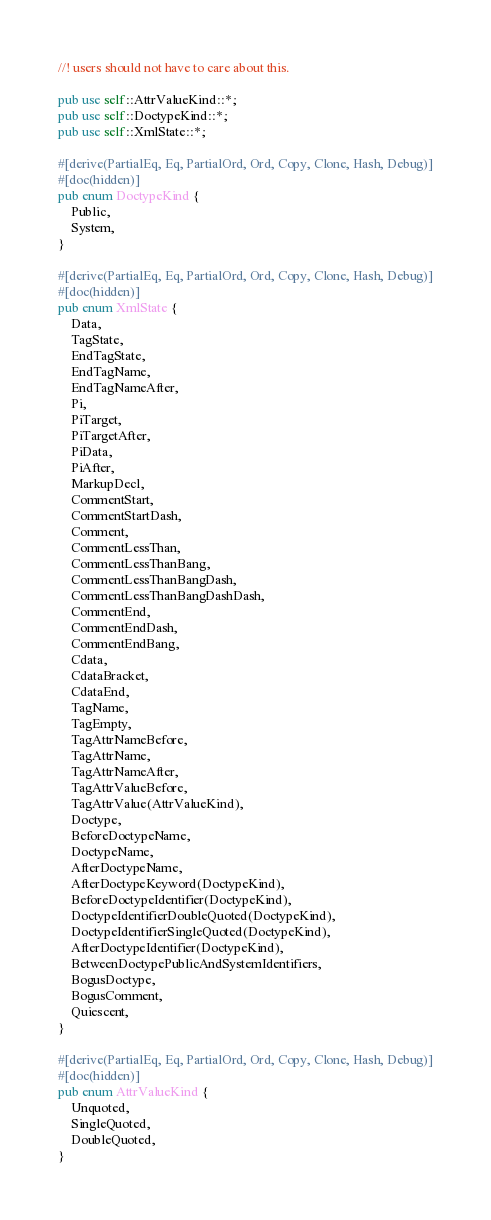<code> <loc_0><loc_0><loc_500><loc_500><_Rust_>//! users should not have to care about this.

pub use self::AttrValueKind::*;
pub use self::DoctypeKind::*;
pub use self::XmlState::*;

#[derive(PartialEq, Eq, PartialOrd, Ord, Copy, Clone, Hash, Debug)]
#[doc(hidden)]
pub enum DoctypeKind {
    Public,
    System,
}

#[derive(PartialEq, Eq, PartialOrd, Ord, Copy, Clone, Hash, Debug)]
#[doc(hidden)]
pub enum XmlState {
    Data,
    TagState,
    EndTagState,
    EndTagName,
    EndTagNameAfter,
    Pi,
    PiTarget,
    PiTargetAfter,
    PiData,
    PiAfter,
    MarkupDecl,
    CommentStart,
    CommentStartDash,
    Comment,
    CommentLessThan,
    CommentLessThanBang,
    CommentLessThanBangDash,
    CommentLessThanBangDashDash,
    CommentEnd,
    CommentEndDash,
    CommentEndBang,
    Cdata,
    CdataBracket,
    CdataEnd,
    TagName,
    TagEmpty,
    TagAttrNameBefore,
    TagAttrName,
    TagAttrNameAfter,
    TagAttrValueBefore,
    TagAttrValue(AttrValueKind),
    Doctype,
    BeforeDoctypeName,
    DoctypeName,
    AfterDoctypeName,
    AfterDoctypeKeyword(DoctypeKind),
    BeforeDoctypeIdentifier(DoctypeKind),
    DoctypeIdentifierDoubleQuoted(DoctypeKind),
    DoctypeIdentifierSingleQuoted(DoctypeKind),
    AfterDoctypeIdentifier(DoctypeKind),
    BetweenDoctypePublicAndSystemIdentifiers,
    BogusDoctype,
    BogusComment,
    Quiescent,
}

#[derive(PartialEq, Eq, PartialOrd, Ord, Copy, Clone, Hash, Debug)]
#[doc(hidden)]
pub enum AttrValueKind {
    Unquoted,
    SingleQuoted,
    DoubleQuoted,
}
</code> 